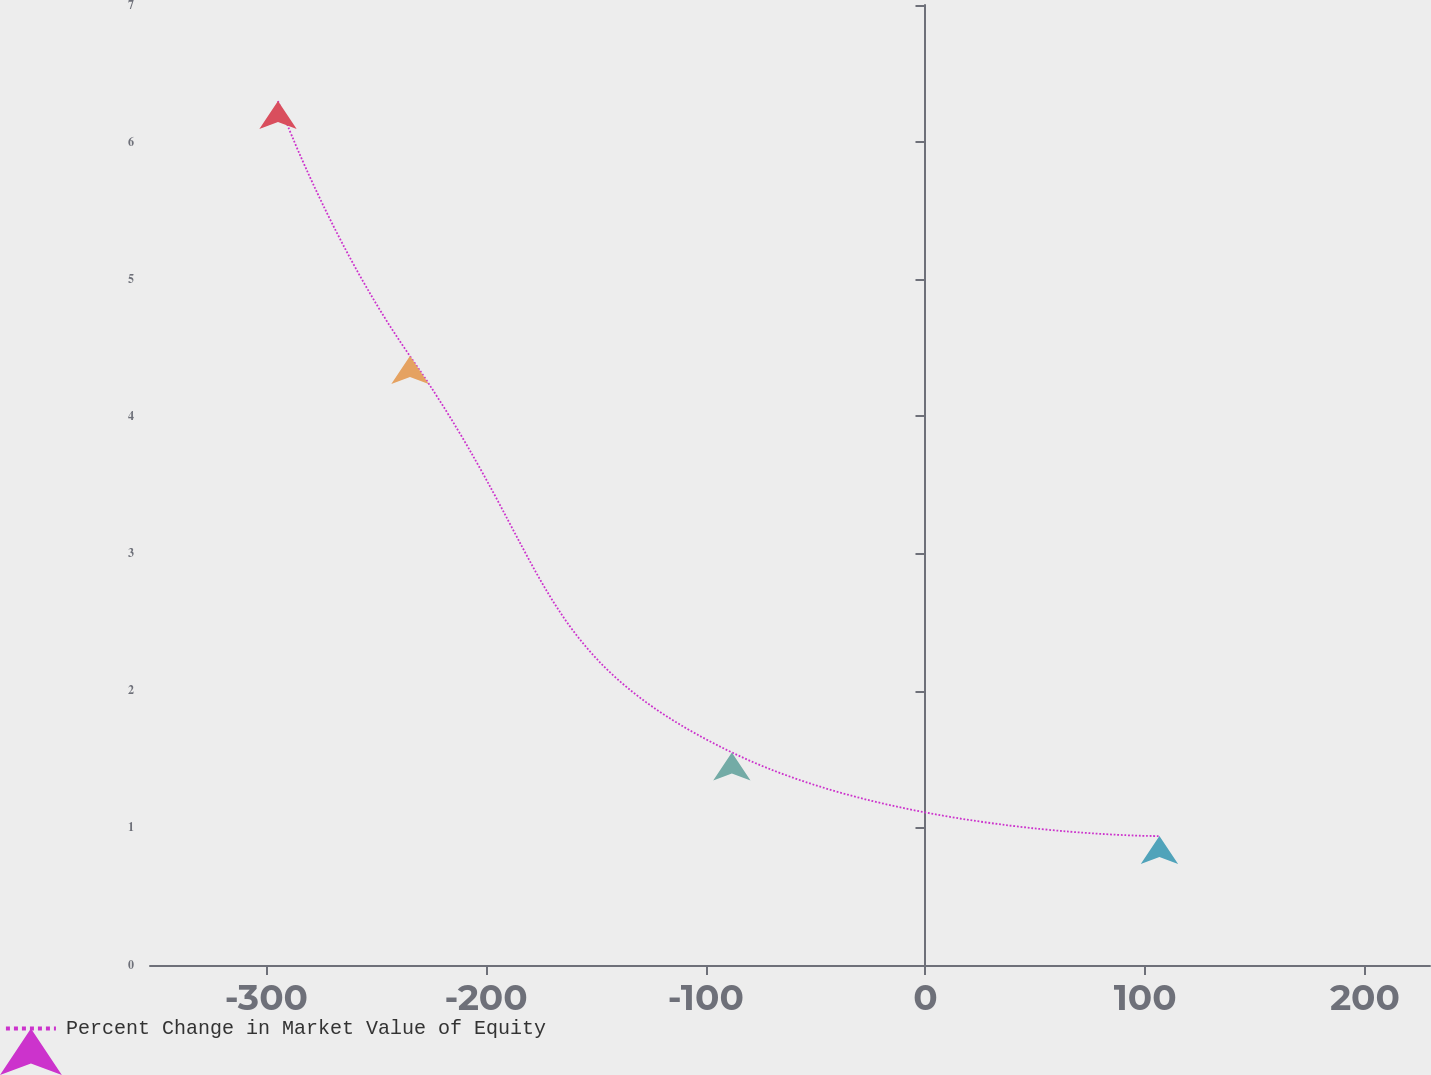Convert chart to OTSL. <chart><loc_0><loc_0><loc_500><loc_500><line_chart><ecel><fcel>Percent Change in Market Value of Equity<nl><fcel>-294.7<fcel>6.3<nl><fcel>-234.63<fcel>4.44<nl><fcel>-88.13<fcel>1.55<nl><fcel>106.47<fcel>0.94<nl><fcel>233.46<fcel>3.9<nl><fcel>287.88<fcel>5.54<nl></chart> 